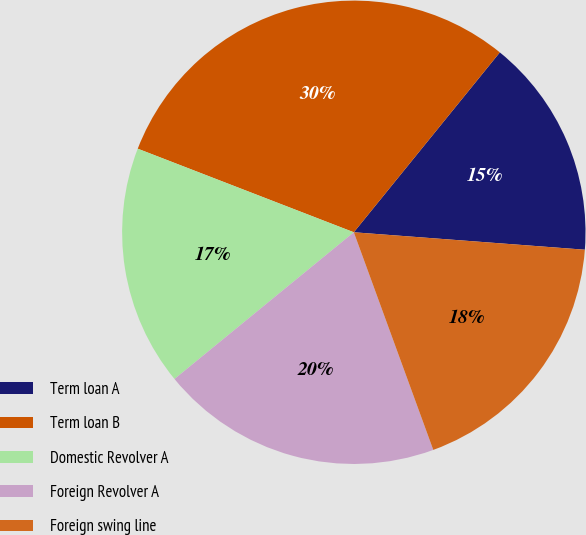Convert chart to OTSL. <chart><loc_0><loc_0><loc_500><loc_500><pie_chart><fcel>Term loan A<fcel>Term loan B<fcel>Domestic Revolver A<fcel>Foreign Revolver A<fcel>Foreign swing line<nl><fcel>15.35%<fcel>29.98%<fcel>16.79%<fcel>19.66%<fcel>18.23%<nl></chart> 